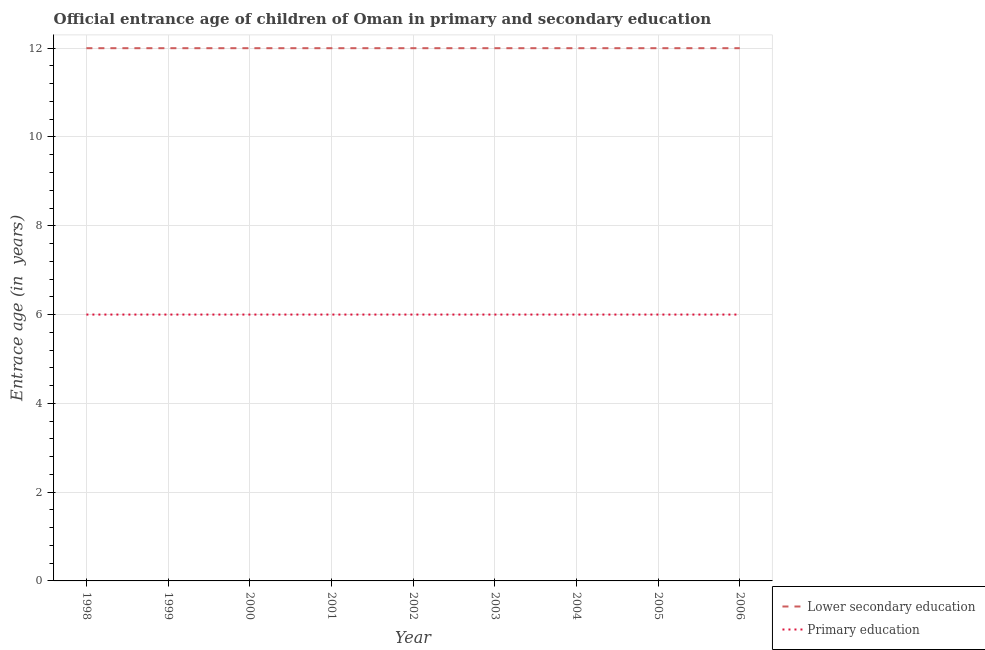What is the entrance age of children in lower secondary education in 2003?
Give a very brief answer. 12. Across all years, what is the maximum entrance age of children in lower secondary education?
Your response must be concise. 12. Across all years, what is the minimum entrance age of children in lower secondary education?
Give a very brief answer. 12. What is the total entrance age of children in lower secondary education in the graph?
Provide a short and direct response. 108. What is the difference between the entrance age of chiildren in primary education in 2006 and the entrance age of children in lower secondary education in 2002?
Your response must be concise. -6. In the year 2005, what is the difference between the entrance age of chiildren in primary education and entrance age of children in lower secondary education?
Your answer should be compact. -6. Is the difference between the entrance age of chiildren in primary education in 2002 and 2003 greater than the difference between the entrance age of children in lower secondary education in 2002 and 2003?
Make the answer very short. No. What is the difference between the highest and the lowest entrance age of chiildren in primary education?
Give a very brief answer. 0. Is the sum of the entrance age of chiildren in primary education in 1999 and 2006 greater than the maximum entrance age of children in lower secondary education across all years?
Your answer should be compact. No. Is the entrance age of chiildren in primary education strictly less than the entrance age of children in lower secondary education over the years?
Provide a short and direct response. Yes. Where does the legend appear in the graph?
Your answer should be very brief. Bottom right. How are the legend labels stacked?
Provide a succinct answer. Vertical. What is the title of the graph?
Give a very brief answer. Official entrance age of children of Oman in primary and secondary education. What is the label or title of the Y-axis?
Ensure brevity in your answer.  Entrace age (in  years). What is the Entrace age (in  years) in Primary education in 1998?
Your response must be concise. 6. What is the Entrace age (in  years) of Lower secondary education in 1999?
Offer a very short reply. 12. What is the Entrace age (in  years) in Lower secondary education in 2000?
Keep it short and to the point. 12. What is the Entrace age (in  years) in Lower secondary education in 2001?
Keep it short and to the point. 12. What is the Entrace age (in  years) of Primary education in 2001?
Ensure brevity in your answer.  6. What is the Entrace age (in  years) of Primary education in 2002?
Offer a very short reply. 6. What is the Entrace age (in  years) of Lower secondary education in 2003?
Your response must be concise. 12. What is the Entrace age (in  years) of Primary education in 2003?
Keep it short and to the point. 6. What is the Entrace age (in  years) in Primary education in 2004?
Ensure brevity in your answer.  6. What is the Entrace age (in  years) of Primary education in 2006?
Your answer should be very brief. 6. Across all years, what is the maximum Entrace age (in  years) of Lower secondary education?
Provide a short and direct response. 12. Across all years, what is the minimum Entrace age (in  years) in Lower secondary education?
Provide a succinct answer. 12. Across all years, what is the minimum Entrace age (in  years) in Primary education?
Provide a short and direct response. 6. What is the total Entrace age (in  years) in Lower secondary education in the graph?
Provide a short and direct response. 108. What is the total Entrace age (in  years) of Primary education in the graph?
Your answer should be very brief. 54. What is the difference between the Entrace age (in  years) in Lower secondary education in 1998 and that in 1999?
Your answer should be compact. 0. What is the difference between the Entrace age (in  years) of Primary education in 1998 and that in 1999?
Ensure brevity in your answer.  0. What is the difference between the Entrace age (in  years) in Lower secondary education in 1998 and that in 2001?
Your response must be concise. 0. What is the difference between the Entrace age (in  years) of Primary education in 1998 and that in 2001?
Your response must be concise. 0. What is the difference between the Entrace age (in  years) of Primary education in 1998 and that in 2002?
Give a very brief answer. 0. What is the difference between the Entrace age (in  years) in Lower secondary education in 1998 and that in 2003?
Give a very brief answer. 0. What is the difference between the Entrace age (in  years) of Primary education in 1998 and that in 2003?
Your answer should be very brief. 0. What is the difference between the Entrace age (in  years) in Lower secondary education in 1999 and that in 2000?
Keep it short and to the point. 0. What is the difference between the Entrace age (in  years) of Primary education in 1999 and that in 2001?
Provide a succinct answer. 0. What is the difference between the Entrace age (in  years) of Lower secondary education in 1999 and that in 2004?
Offer a terse response. 0. What is the difference between the Entrace age (in  years) of Primary education in 1999 and that in 2005?
Offer a very short reply. 0. What is the difference between the Entrace age (in  years) of Primary education in 1999 and that in 2006?
Your response must be concise. 0. What is the difference between the Entrace age (in  years) of Lower secondary education in 2000 and that in 2001?
Offer a very short reply. 0. What is the difference between the Entrace age (in  years) of Primary education in 2000 and that in 2001?
Give a very brief answer. 0. What is the difference between the Entrace age (in  years) in Primary education in 2000 and that in 2003?
Provide a short and direct response. 0. What is the difference between the Entrace age (in  years) in Lower secondary education in 2000 and that in 2004?
Make the answer very short. 0. What is the difference between the Entrace age (in  years) of Primary education in 2000 and that in 2004?
Your response must be concise. 0. What is the difference between the Entrace age (in  years) of Lower secondary education in 2000 and that in 2006?
Your response must be concise. 0. What is the difference between the Entrace age (in  years) in Primary education in 2000 and that in 2006?
Your answer should be very brief. 0. What is the difference between the Entrace age (in  years) in Lower secondary education in 2001 and that in 2003?
Your answer should be very brief. 0. What is the difference between the Entrace age (in  years) in Primary education in 2001 and that in 2003?
Give a very brief answer. 0. What is the difference between the Entrace age (in  years) in Lower secondary education in 2001 and that in 2004?
Provide a short and direct response. 0. What is the difference between the Entrace age (in  years) in Primary education in 2001 and that in 2004?
Offer a terse response. 0. What is the difference between the Entrace age (in  years) in Lower secondary education in 2001 and that in 2005?
Ensure brevity in your answer.  0. What is the difference between the Entrace age (in  years) of Primary education in 2001 and that in 2005?
Provide a short and direct response. 0. What is the difference between the Entrace age (in  years) of Primary education in 2002 and that in 2003?
Provide a short and direct response. 0. What is the difference between the Entrace age (in  years) of Lower secondary education in 2002 and that in 2005?
Offer a terse response. 0. What is the difference between the Entrace age (in  years) of Lower secondary education in 2003 and that in 2004?
Give a very brief answer. 0. What is the difference between the Entrace age (in  years) in Primary education in 2003 and that in 2004?
Offer a terse response. 0. What is the difference between the Entrace age (in  years) of Primary education in 2003 and that in 2005?
Your answer should be compact. 0. What is the difference between the Entrace age (in  years) of Primary education in 2003 and that in 2006?
Your answer should be compact. 0. What is the difference between the Entrace age (in  years) of Lower secondary education in 2004 and that in 2005?
Offer a terse response. 0. What is the difference between the Entrace age (in  years) in Primary education in 2004 and that in 2005?
Give a very brief answer. 0. What is the difference between the Entrace age (in  years) in Lower secondary education in 2004 and that in 2006?
Ensure brevity in your answer.  0. What is the difference between the Entrace age (in  years) of Primary education in 2004 and that in 2006?
Offer a terse response. 0. What is the difference between the Entrace age (in  years) of Primary education in 2005 and that in 2006?
Ensure brevity in your answer.  0. What is the difference between the Entrace age (in  years) in Lower secondary education in 1998 and the Entrace age (in  years) in Primary education in 1999?
Offer a very short reply. 6. What is the difference between the Entrace age (in  years) of Lower secondary education in 1998 and the Entrace age (in  years) of Primary education in 2001?
Keep it short and to the point. 6. What is the difference between the Entrace age (in  years) in Lower secondary education in 1998 and the Entrace age (in  years) in Primary education in 2006?
Your response must be concise. 6. What is the difference between the Entrace age (in  years) in Lower secondary education in 1999 and the Entrace age (in  years) in Primary education in 2001?
Your response must be concise. 6. What is the difference between the Entrace age (in  years) in Lower secondary education in 1999 and the Entrace age (in  years) in Primary education in 2005?
Give a very brief answer. 6. What is the difference between the Entrace age (in  years) in Lower secondary education in 1999 and the Entrace age (in  years) in Primary education in 2006?
Provide a succinct answer. 6. What is the difference between the Entrace age (in  years) in Lower secondary education in 2000 and the Entrace age (in  years) in Primary education in 2001?
Your answer should be very brief. 6. What is the difference between the Entrace age (in  years) in Lower secondary education in 2000 and the Entrace age (in  years) in Primary education in 2004?
Provide a short and direct response. 6. What is the difference between the Entrace age (in  years) in Lower secondary education in 2001 and the Entrace age (in  years) in Primary education in 2002?
Provide a short and direct response. 6. What is the difference between the Entrace age (in  years) of Lower secondary education in 2001 and the Entrace age (in  years) of Primary education in 2004?
Ensure brevity in your answer.  6. What is the difference between the Entrace age (in  years) of Lower secondary education in 2002 and the Entrace age (in  years) of Primary education in 2006?
Keep it short and to the point. 6. What is the difference between the Entrace age (in  years) of Lower secondary education in 2003 and the Entrace age (in  years) of Primary education in 2004?
Keep it short and to the point. 6. What is the difference between the Entrace age (in  years) in Lower secondary education in 2003 and the Entrace age (in  years) in Primary education in 2006?
Provide a short and direct response. 6. What is the difference between the Entrace age (in  years) in Lower secondary education in 2004 and the Entrace age (in  years) in Primary education in 2005?
Give a very brief answer. 6. What is the difference between the Entrace age (in  years) in Lower secondary education in 2004 and the Entrace age (in  years) in Primary education in 2006?
Your response must be concise. 6. What is the difference between the Entrace age (in  years) in Lower secondary education in 2005 and the Entrace age (in  years) in Primary education in 2006?
Provide a succinct answer. 6. What is the average Entrace age (in  years) of Lower secondary education per year?
Your answer should be compact. 12. What is the average Entrace age (in  years) in Primary education per year?
Your answer should be very brief. 6. In the year 1999, what is the difference between the Entrace age (in  years) of Lower secondary education and Entrace age (in  years) of Primary education?
Offer a very short reply. 6. In the year 2002, what is the difference between the Entrace age (in  years) of Lower secondary education and Entrace age (in  years) of Primary education?
Offer a very short reply. 6. In the year 2003, what is the difference between the Entrace age (in  years) in Lower secondary education and Entrace age (in  years) in Primary education?
Provide a short and direct response. 6. In the year 2005, what is the difference between the Entrace age (in  years) in Lower secondary education and Entrace age (in  years) in Primary education?
Your answer should be very brief. 6. In the year 2006, what is the difference between the Entrace age (in  years) of Lower secondary education and Entrace age (in  years) of Primary education?
Give a very brief answer. 6. What is the ratio of the Entrace age (in  years) in Lower secondary education in 1998 to that in 1999?
Keep it short and to the point. 1. What is the ratio of the Entrace age (in  years) of Lower secondary education in 1998 to that in 2000?
Keep it short and to the point. 1. What is the ratio of the Entrace age (in  years) in Primary education in 1998 to that in 2000?
Provide a short and direct response. 1. What is the ratio of the Entrace age (in  years) in Lower secondary education in 1998 to that in 2001?
Keep it short and to the point. 1. What is the ratio of the Entrace age (in  years) in Primary education in 1998 to that in 2002?
Your response must be concise. 1. What is the ratio of the Entrace age (in  years) in Lower secondary education in 1998 to that in 2003?
Your response must be concise. 1. What is the ratio of the Entrace age (in  years) of Primary education in 1998 to that in 2003?
Ensure brevity in your answer.  1. What is the ratio of the Entrace age (in  years) of Primary education in 1998 to that in 2004?
Provide a short and direct response. 1. What is the ratio of the Entrace age (in  years) in Primary education in 1998 to that in 2005?
Provide a succinct answer. 1. What is the ratio of the Entrace age (in  years) in Lower secondary education in 1998 to that in 2006?
Provide a succinct answer. 1. What is the ratio of the Entrace age (in  years) in Primary education in 1999 to that in 2001?
Provide a succinct answer. 1. What is the ratio of the Entrace age (in  years) in Primary education in 1999 to that in 2002?
Your answer should be very brief. 1. What is the ratio of the Entrace age (in  years) in Primary education in 1999 to that in 2003?
Ensure brevity in your answer.  1. What is the ratio of the Entrace age (in  years) in Lower secondary education in 1999 to that in 2004?
Give a very brief answer. 1. What is the ratio of the Entrace age (in  years) in Primary education in 1999 to that in 2004?
Make the answer very short. 1. What is the ratio of the Entrace age (in  years) in Primary education in 1999 to that in 2005?
Make the answer very short. 1. What is the ratio of the Entrace age (in  years) of Lower secondary education in 1999 to that in 2006?
Your answer should be very brief. 1. What is the ratio of the Entrace age (in  years) of Primary education in 1999 to that in 2006?
Your answer should be very brief. 1. What is the ratio of the Entrace age (in  years) in Primary education in 2000 to that in 2002?
Keep it short and to the point. 1. What is the ratio of the Entrace age (in  years) in Primary education in 2000 to that in 2003?
Provide a succinct answer. 1. What is the ratio of the Entrace age (in  years) in Primary education in 2000 to that in 2005?
Offer a very short reply. 1. What is the ratio of the Entrace age (in  years) in Lower secondary education in 2000 to that in 2006?
Provide a short and direct response. 1. What is the ratio of the Entrace age (in  years) of Primary education in 2000 to that in 2006?
Your response must be concise. 1. What is the ratio of the Entrace age (in  years) of Lower secondary education in 2001 to that in 2002?
Your response must be concise. 1. What is the ratio of the Entrace age (in  years) in Primary education in 2001 to that in 2002?
Keep it short and to the point. 1. What is the ratio of the Entrace age (in  years) of Primary education in 2001 to that in 2003?
Provide a short and direct response. 1. What is the ratio of the Entrace age (in  years) of Primary education in 2001 to that in 2004?
Your answer should be very brief. 1. What is the ratio of the Entrace age (in  years) of Lower secondary education in 2001 to that in 2005?
Your answer should be very brief. 1. What is the ratio of the Entrace age (in  years) in Lower secondary education in 2001 to that in 2006?
Your answer should be very brief. 1. What is the ratio of the Entrace age (in  years) in Lower secondary education in 2002 to that in 2003?
Make the answer very short. 1. What is the ratio of the Entrace age (in  years) in Primary education in 2002 to that in 2003?
Provide a succinct answer. 1. What is the ratio of the Entrace age (in  years) in Lower secondary education in 2002 to that in 2005?
Provide a succinct answer. 1. What is the ratio of the Entrace age (in  years) in Primary education in 2002 to that in 2005?
Your answer should be compact. 1. What is the ratio of the Entrace age (in  years) of Lower secondary education in 2002 to that in 2006?
Your answer should be compact. 1. What is the ratio of the Entrace age (in  years) in Primary education in 2003 to that in 2004?
Your answer should be very brief. 1. What is the ratio of the Entrace age (in  years) of Lower secondary education in 2003 to that in 2006?
Offer a very short reply. 1. What is the ratio of the Entrace age (in  years) of Primary education in 2003 to that in 2006?
Give a very brief answer. 1. What is the ratio of the Entrace age (in  years) in Lower secondary education in 2004 to that in 2005?
Ensure brevity in your answer.  1. What is the ratio of the Entrace age (in  years) of Lower secondary education in 2005 to that in 2006?
Give a very brief answer. 1. What is the difference between the highest and the second highest Entrace age (in  years) in Primary education?
Your answer should be very brief. 0. 